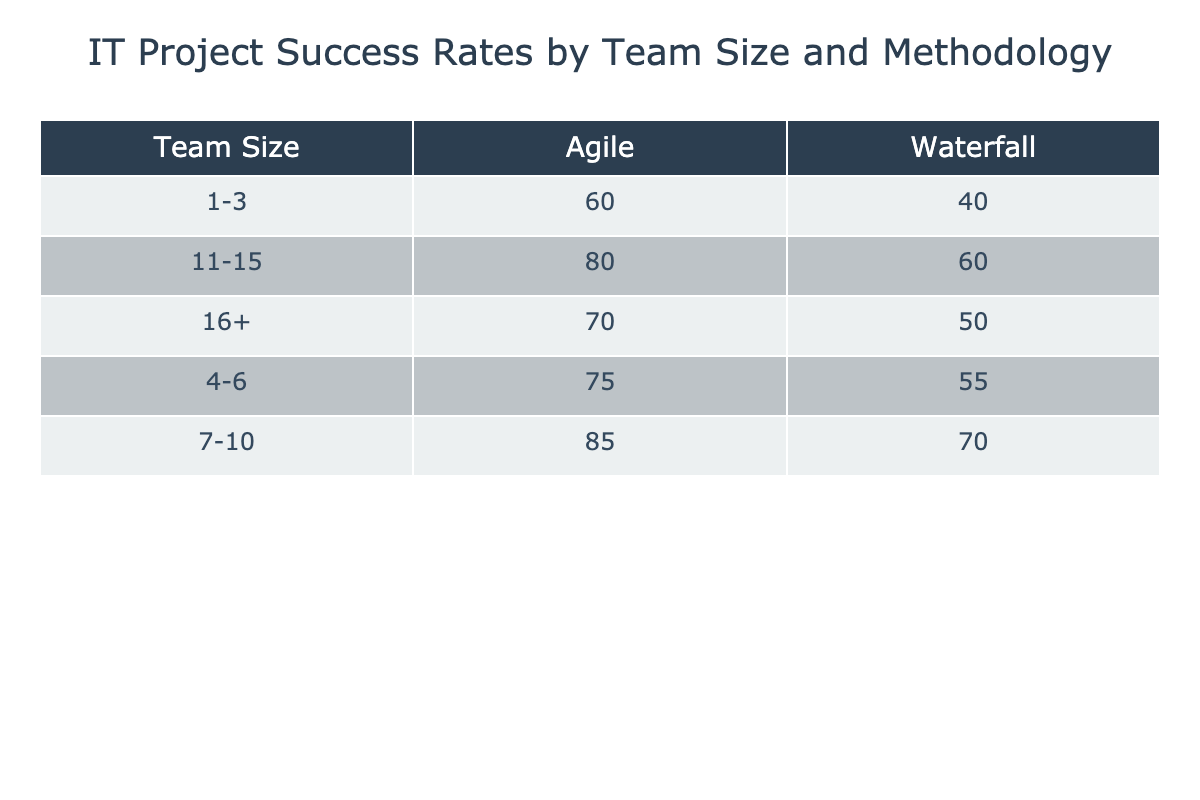What is the success rate for Agile methodology with a team size of 1-3? The table shows the success rate for Agile methodology when the team size is 1-3, which is listed as 60%.
Answer: 60% What is the highest success rate for Waterfall methodology? The highest success rate for Waterfall is found by looking at all the Waterfall success rates. The values are 40, 55, 70, 60, and 50. The maximum of these values is 70%.
Answer: 70% Which team size has the lowest success rate for Agile methodology? To identify the team size with the lowest success rate for Agile, we check the Agile success rates: 60, 75, 85, 80, and 70. The smallest value is 60%, which corresponds to the team size of 1-3.
Answer: 1-3 Is the success rate for team size 11-15 higher in Agile than in Waterfall? The Agile success rate for team size 11-15 is 80%, while the Waterfall success rate is 60%. Since 80% is greater than 60%, the statement is true.
Answer: Yes What is the average success rate for all team sizes using the Waterfall methodology? The success rates for Waterfall are 40, 55, 70, 60, and 50. To find the average, we first sum these values: 40 + 55 + 70 + 60 + 50 = 275. Then we divide by the number of data points, which is 5: 275 / 5 = 55.
Answer: 55 Which methodology is generally more successful across all team sizes? To determine which methodology is generally more successful, we evaluate the average success rates for each methodology. For Waterfall: (40 + 55 + 70 + 60 + 50) / 5 = 55. For Agile: (60 + 75 + 85 + 80 + 70) / 5 = 72. Since 72 is greater than 55, Agile is more successful.
Answer: Agile How many methodology types have a success rate of 75% or higher among team sizes of 4-6? In the table, for team sizes of 4-6, the success rates are 55% for Waterfall and 75% for Agile. Therefore, only the Agile methodology meets the criterion of 75% or higher.
Answer: 1 Which team size gives a better success rate with the Agile methodology compared to Waterfall? By comparing the success rates: for team size 1-3, Agile (60%) is better; for 4-6, Agile (75%) is better; for 7-10, Agile (85%) is better; for 11-15, Agile (80%) is better; and for 16+, Agile (70%) is better. Thus, Agile methodology consistently outperforms Waterfall for all team sizes.
Answer: All team sizes 